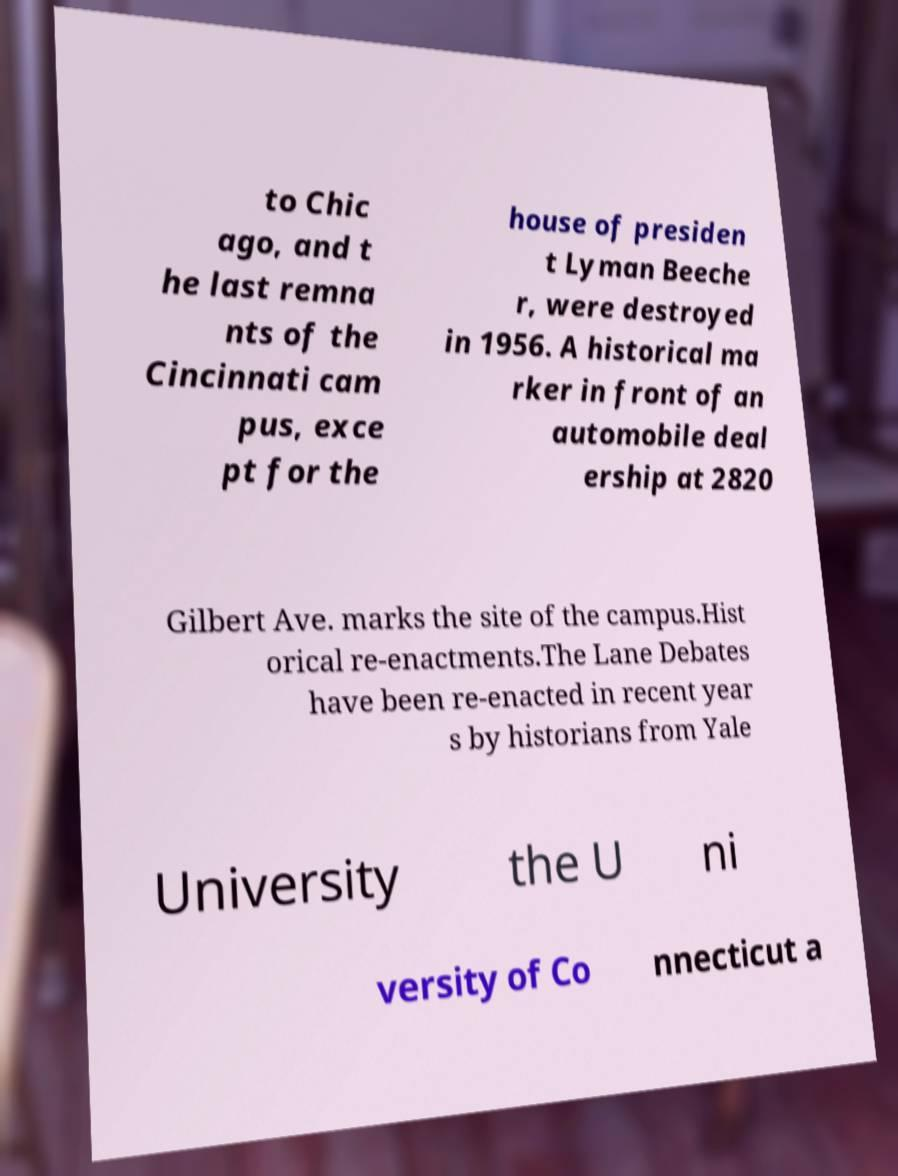What messages or text are displayed in this image? I need them in a readable, typed format. to Chic ago, and t he last remna nts of the Cincinnati cam pus, exce pt for the house of presiden t Lyman Beeche r, were destroyed in 1956. A historical ma rker in front of an automobile deal ership at 2820 Gilbert Ave. marks the site of the campus.Hist orical re-enactments.The Lane Debates have been re-enacted in recent year s by historians from Yale University the U ni versity of Co nnecticut a 